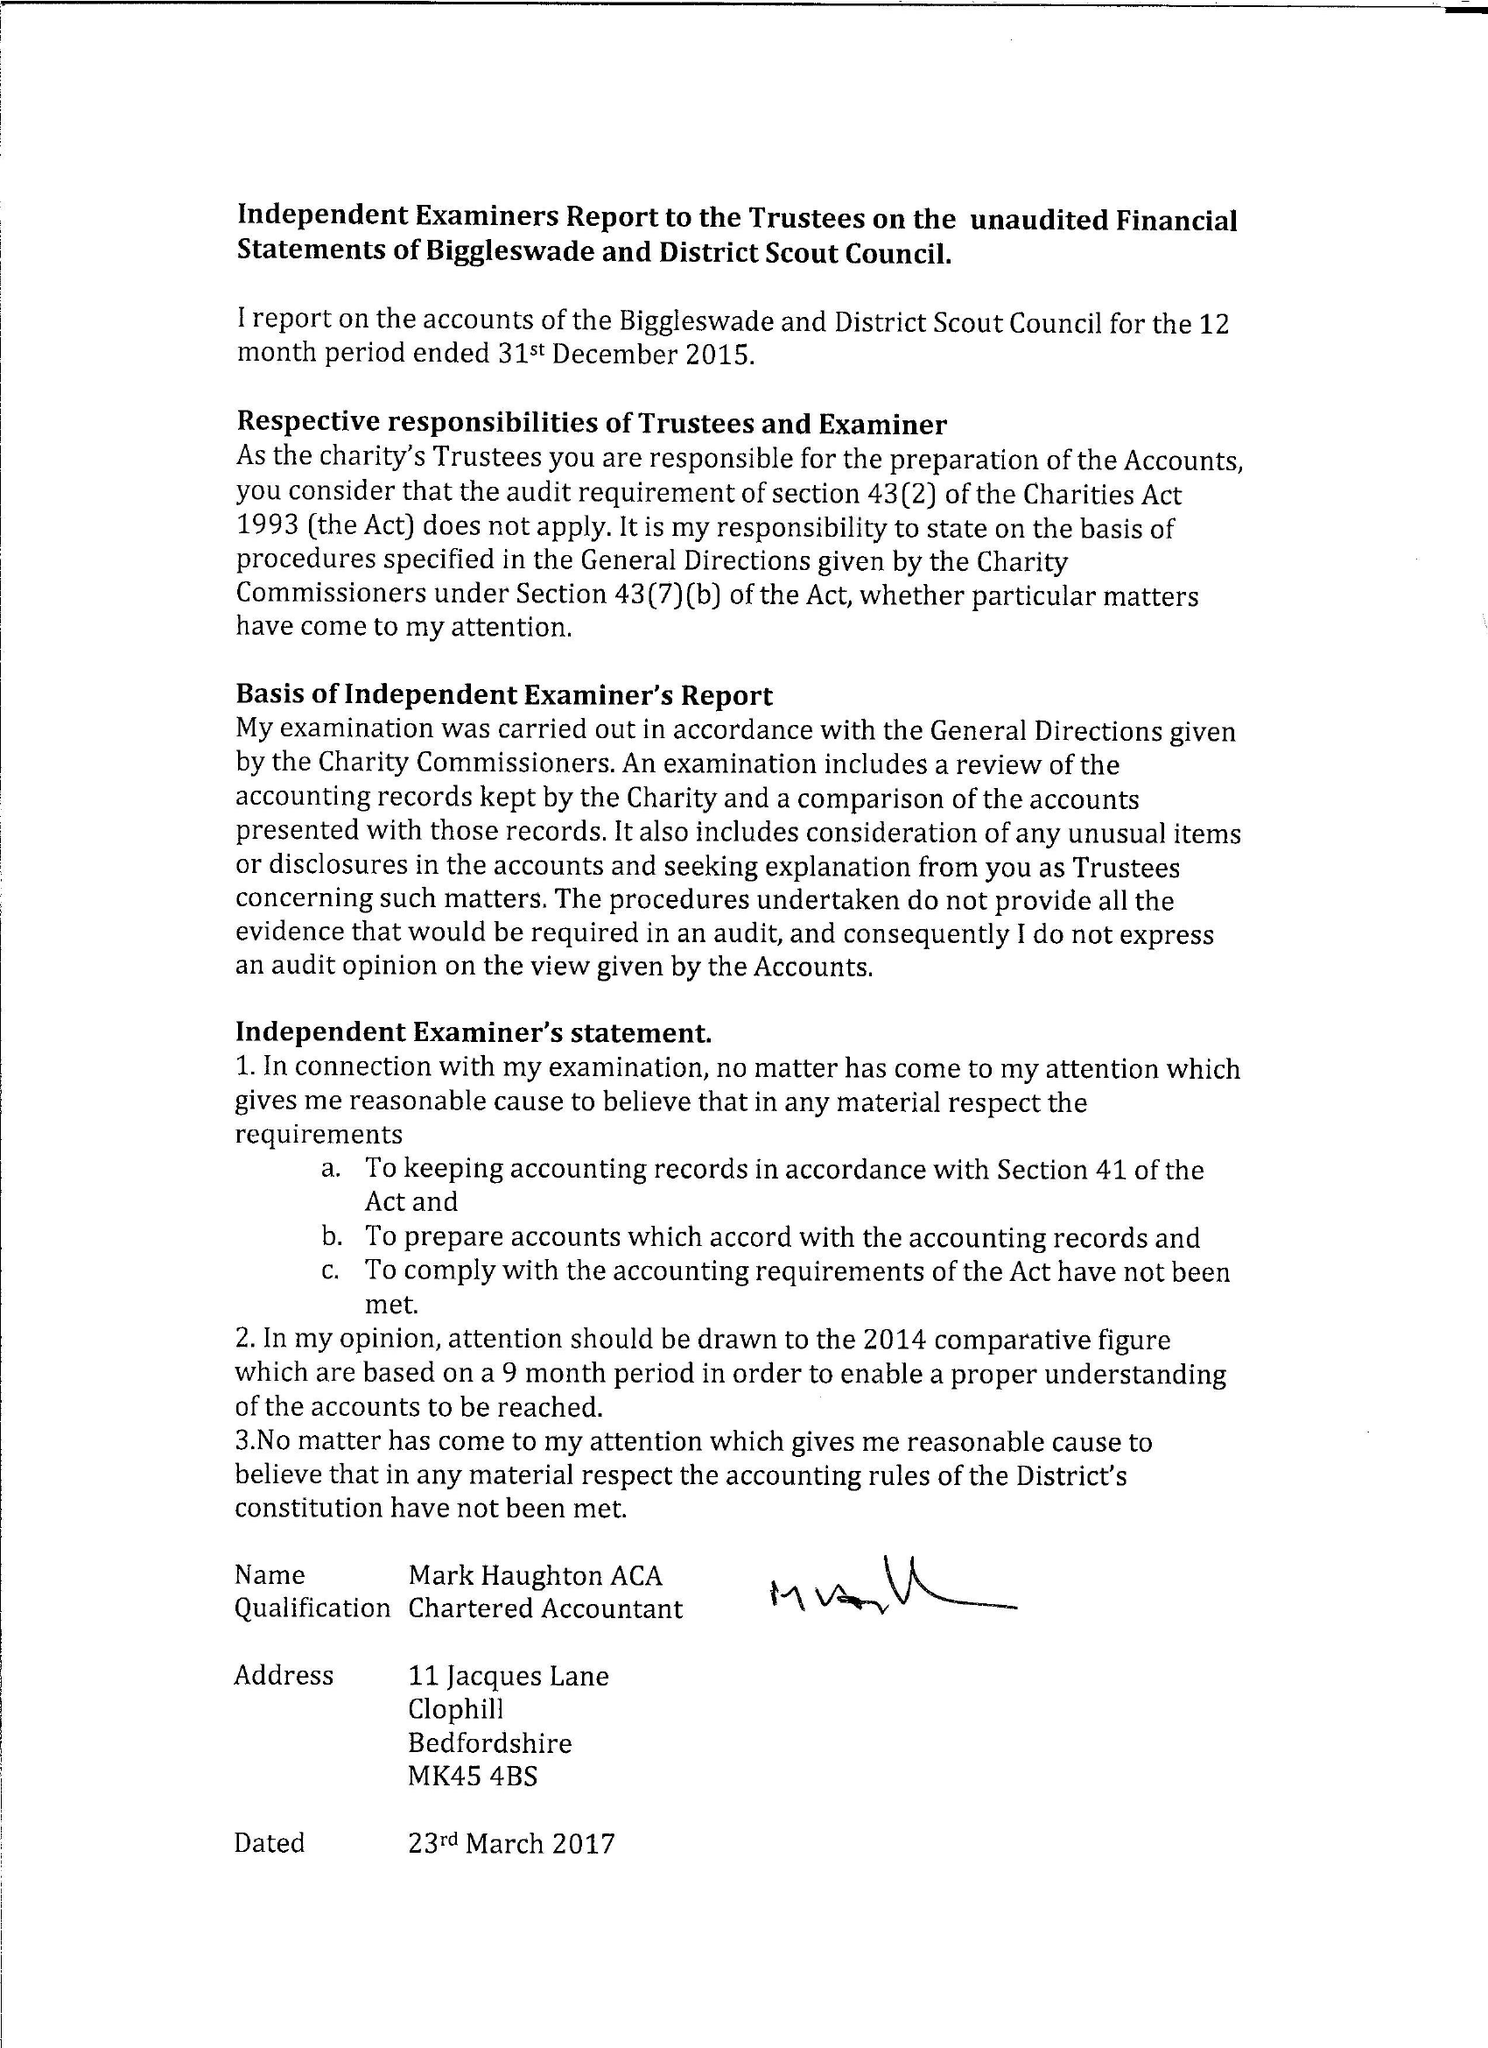What is the value for the income_annually_in_british_pounds?
Answer the question using a single word or phrase. 52470.00 